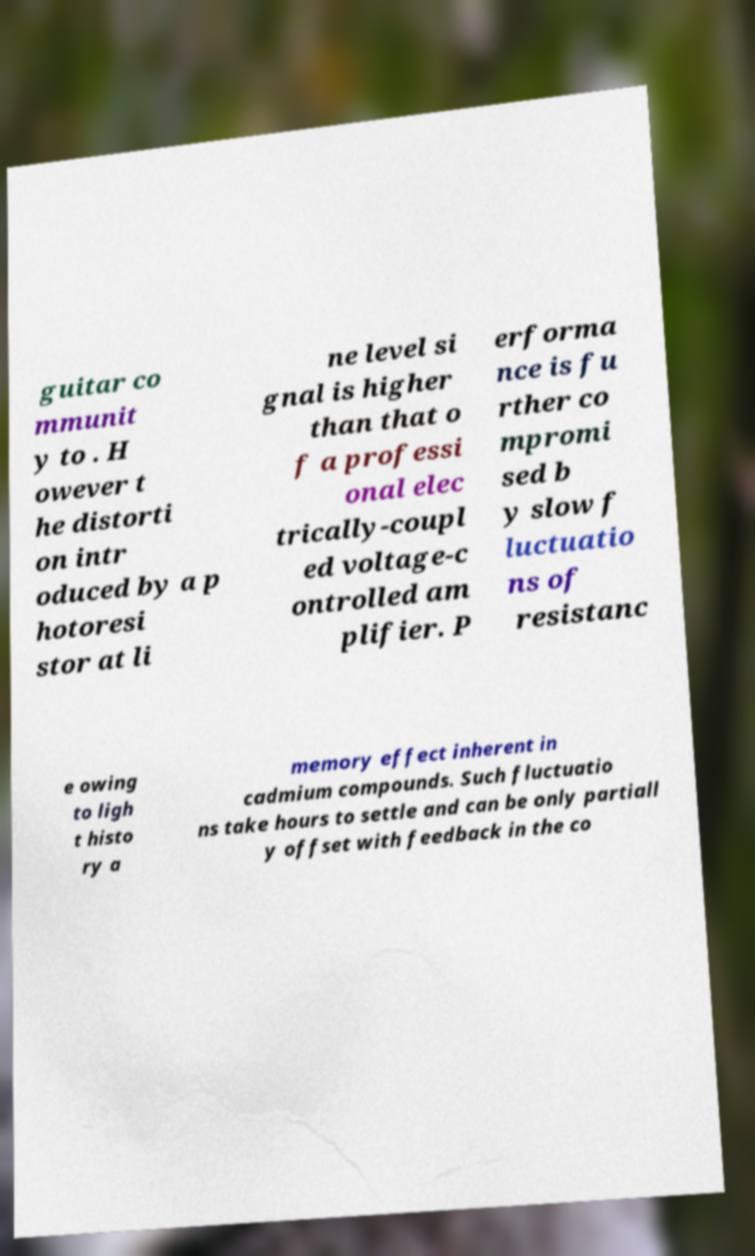Can you read and provide the text displayed in the image?This photo seems to have some interesting text. Can you extract and type it out for me? guitar co mmunit y to . H owever t he distorti on intr oduced by a p hotoresi stor at li ne level si gnal is higher than that o f a professi onal elec trically-coupl ed voltage-c ontrolled am plifier. P erforma nce is fu rther co mpromi sed b y slow f luctuatio ns of resistanc e owing to ligh t histo ry a memory effect inherent in cadmium compounds. Such fluctuatio ns take hours to settle and can be only partiall y offset with feedback in the co 